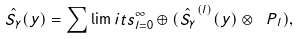Convert formula to latex. <formula><loc_0><loc_0><loc_500><loc_500>\hat { S _ { \gamma } } ( y ) = \sum \lim i t s _ { l = 0 } ^ { \infty } \oplus ( \hat { S _ { \gamma } } ^ { ( l ) } ( y ) \otimes { \ P } _ { l } ) ,</formula> 